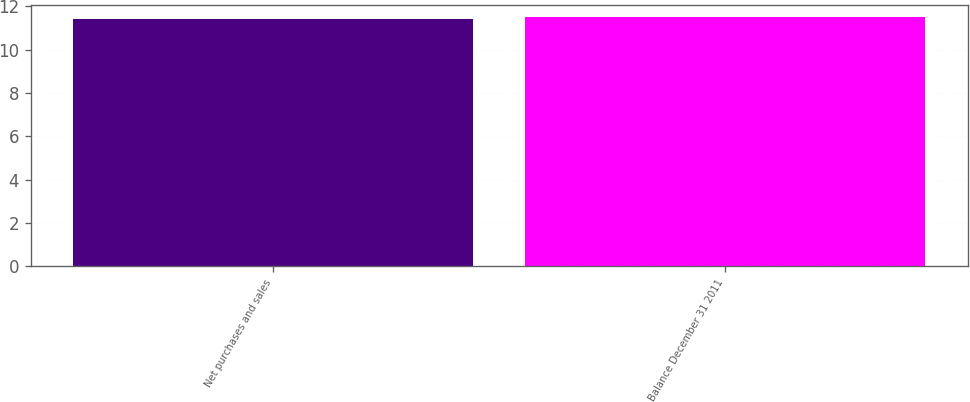Convert chart. <chart><loc_0><loc_0><loc_500><loc_500><bar_chart><fcel>Net purchases and sales<fcel>Balance December 31 2011<nl><fcel>11.4<fcel>11.5<nl></chart> 